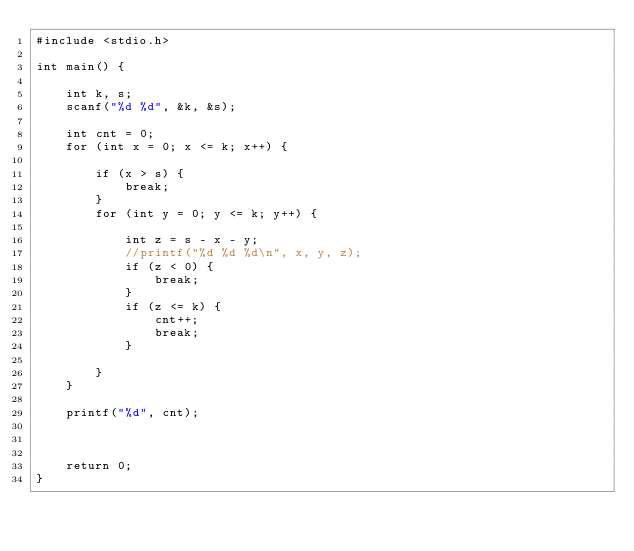<code> <loc_0><loc_0><loc_500><loc_500><_C_>#include <stdio.h>

int main() {

    int k, s;
    scanf("%d %d", &k, &s);

    int cnt = 0;
    for (int x = 0; x <= k; x++) {

        if (x > s) {
            break;
        }
        for (int y = 0; y <= k; y++) {

            int z = s - x - y;
            //printf("%d %d %d\n", x, y, z);
            if (z < 0) {
                break;
            }
            if (z <= k) {
                cnt++;
                break;
            }

        }
    }

    printf("%d", cnt);



    return 0;
}
</code> 